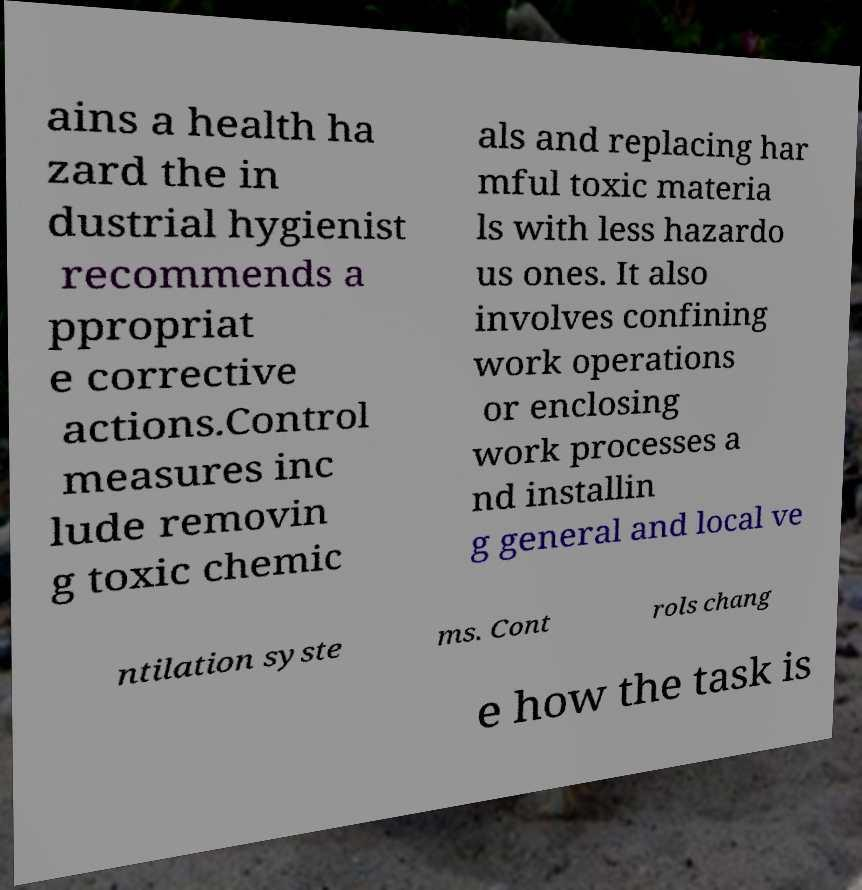Can you read and provide the text displayed in the image?This photo seems to have some interesting text. Can you extract and type it out for me? ains a health ha zard the in dustrial hygienist recommends a ppropriat e corrective actions.Control measures inc lude removin g toxic chemic als and replacing har mful toxic materia ls with less hazardo us ones. It also involves confining work operations or enclosing work processes a nd installin g general and local ve ntilation syste ms. Cont rols chang e how the task is 